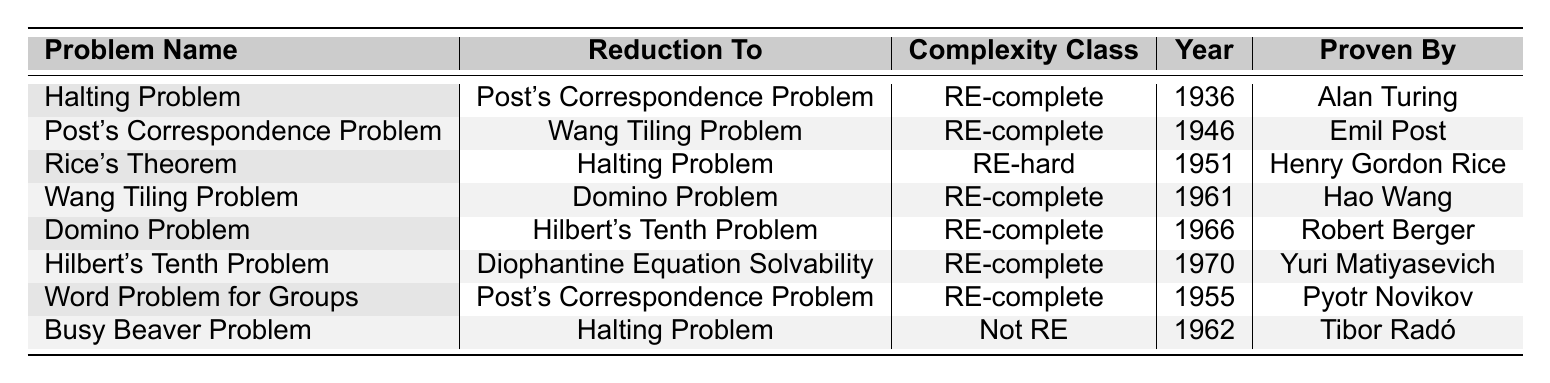What is the complexity class of the Halting Problem? The Halting Problem is specifically listed in the table with its complexity class noted in that row. It is categorized as RE-complete.
Answer: RE-complete In which year was the Post's Correspondence Problem proven undecidable? To find this information, I look at the row for the Post's Correspondence Problem in the table, which states it was proven in 1946.
Answer: 1946 Who proved the Domino Problem to be undecidable? The table lists the relevant row for the Domino Problem, where it indicates that Robert Berger was the one who proved it undecidable.
Answer: Robert Berger Which problems are mapped to the Halting Problem through reductions? By examining the table, I find that the Halting Problem is related to two reductions: it is mapped from Rice's Theorem and also is reduced to the Busy Beaver Problem.
Answer: Rice's Theorem, Busy Beaver Problem How many problems in the table are classified as RE-complete? I review each row in the table and count the instances labeled as RE-complete: Halting Problem, Post's Correspondence Problem, Wang Tiling Problem, Domino Problem, Hilbert's Tenth Problem, and Word Problem for Groups. This totals 6 problems.
Answer: 6 Is the Busy Beaver Problem proven as RE-complete? I check the row for the Busy Beaver Problem and see that it is classified as Not RE, therefore it is not proven to be RE-complete.
Answer: No What is the sequence of reductions from the Post's Correspondence Problem? In the table, the Post's Correspondence Problem first reduces to the Wang Tiling Problem. Hence, the sequence is straightforward: Post's Correspondence Problem → Wang Tiling Problem.
Answer: Post's Correspondence Problem → Wang Tiling Problem What is the complexity class of the problem that was proven undecidable in 1951? Referring to the table, I locate the year 1951 under Rice's Theorem. It is classified as RE-hard.
Answer: RE-hard Which reduction leads to Diophantine Equation Solvability? The row for Hilbert's Tenth Problem shows it reduces to Diophantine Equation Solvability. Therefore, Hilbert's Tenth Problem is the answer.
Answer: Hilbert's Tenth Problem Can you list the names of all the authors who proved undecidable problems in the table? I analyze the 'Proven By' column and extract the names: Alan Turing, Emil Post, Henry Gordon Rice, Hao Wang, Robert Berger, Yuri Matiyasevich, Pyotr Novikov, Tibor Radó. This gives me a complete list.
Answer: Alan Turing, Emil Post, Henry Gordon Rice, Hao Wang, Robert Berger, Yuri Matiyasevich, Pyotr Novikov, Tibor Radó 